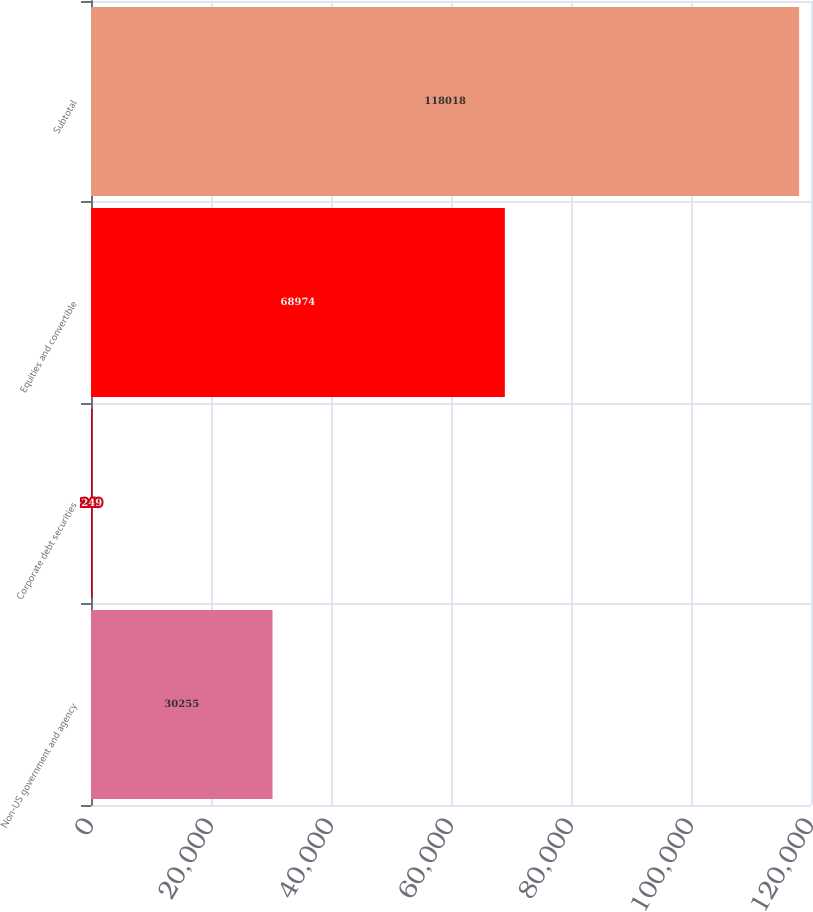Convert chart. <chart><loc_0><loc_0><loc_500><loc_500><bar_chart><fcel>Non-US government and agency<fcel>Corporate debt securities<fcel>Equities and convertible<fcel>Subtotal<nl><fcel>30255<fcel>249<fcel>68974<fcel>118018<nl></chart> 